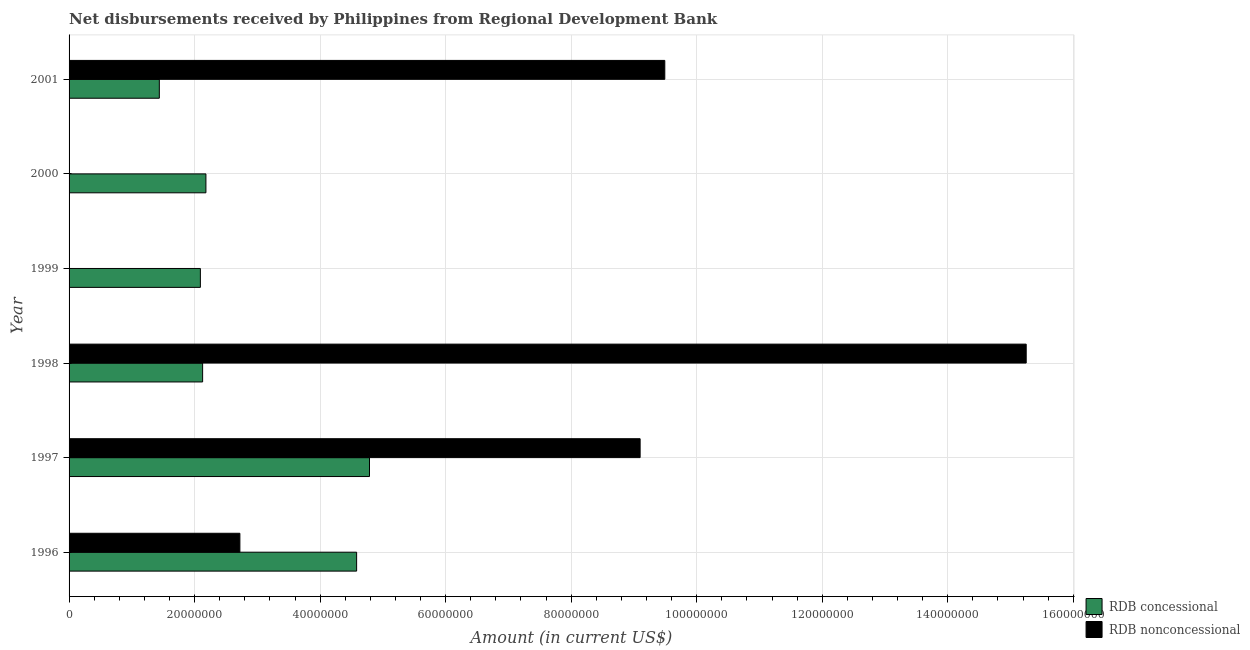Are the number of bars per tick equal to the number of legend labels?
Give a very brief answer. No. What is the label of the 6th group of bars from the top?
Offer a terse response. 1996. What is the net non concessional disbursements from rdb in 2001?
Give a very brief answer. 9.49e+07. Across all years, what is the maximum net non concessional disbursements from rdb?
Ensure brevity in your answer.  1.53e+08. Across all years, what is the minimum net concessional disbursements from rdb?
Offer a terse response. 1.44e+07. What is the total net non concessional disbursements from rdb in the graph?
Make the answer very short. 3.66e+08. What is the difference between the net concessional disbursements from rdb in 1996 and that in 2001?
Make the answer very short. 3.14e+07. What is the difference between the net concessional disbursements from rdb in 2000 and the net non concessional disbursements from rdb in 1998?
Your response must be concise. -1.31e+08. What is the average net non concessional disbursements from rdb per year?
Your response must be concise. 6.09e+07. In the year 1998, what is the difference between the net non concessional disbursements from rdb and net concessional disbursements from rdb?
Your answer should be very brief. 1.31e+08. What is the ratio of the net concessional disbursements from rdb in 1996 to that in 2001?
Keep it short and to the point. 3.19. Is the net concessional disbursements from rdb in 1996 less than that in 2000?
Your answer should be compact. No. What is the difference between the highest and the second highest net concessional disbursements from rdb?
Offer a very short reply. 2.05e+06. What is the difference between the highest and the lowest net concessional disbursements from rdb?
Offer a very short reply. 3.35e+07. In how many years, is the net non concessional disbursements from rdb greater than the average net non concessional disbursements from rdb taken over all years?
Give a very brief answer. 3. How many bars are there?
Your response must be concise. 10. How many years are there in the graph?
Provide a succinct answer. 6. What is the difference between two consecutive major ticks on the X-axis?
Give a very brief answer. 2.00e+07. Does the graph contain any zero values?
Offer a very short reply. Yes. Where does the legend appear in the graph?
Keep it short and to the point. Bottom right. How are the legend labels stacked?
Your answer should be very brief. Vertical. What is the title of the graph?
Offer a very short reply. Net disbursements received by Philippines from Regional Development Bank. Does "Domestic Liabilities" appear as one of the legend labels in the graph?
Make the answer very short. No. What is the label or title of the X-axis?
Your answer should be very brief. Amount (in current US$). What is the Amount (in current US$) of RDB concessional in 1996?
Your answer should be compact. 4.58e+07. What is the Amount (in current US$) in RDB nonconcessional in 1996?
Your response must be concise. 2.72e+07. What is the Amount (in current US$) of RDB concessional in 1997?
Offer a very short reply. 4.79e+07. What is the Amount (in current US$) in RDB nonconcessional in 1997?
Make the answer very short. 9.10e+07. What is the Amount (in current US$) in RDB concessional in 1998?
Provide a succinct answer. 2.13e+07. What is the Amount (in current US$) of RDB nonconcessional in 1998?
Offer a very short reply. 1.53e+08. What is the Amount (in current US$) in RDB concessional in 1999?
Keep it short and to the point. 2.09e+07. What is the Amount (in current US$) of RDB nonconcessional in 1999?
Keep it short and to the point. 0. What is the Amount (in current US$) of RDB concessional in 2000?
Your response must be concise. 2.18e+07. What is the Amount (in current US$) of RDB concessional in 2001?
Your response must be concise. 1.44e+07. What is the Amount (in current US$) in RDB nonconcessional in 2001?
Your answer should be very brief. 9.49e+07. Across all years, what is the maximum Amount (in current US$) in RDB concessional?
Provide a succinct answer. 4.79e+07. Across all years, what is the maximum Amount (in current US$) in RDB nonconcessional?
Give a very brief answer. 1.53e+08. Across all years, what is the minimum Amount (in current US$) in RDB concessional?
Provide a short and direct response. 1.44e+07. Across all years, what is the minimum Amount (in current US$) in RDB nonconcessional?
Your answer should be compact. 0. What is the total Amount (in current US$) of RDB concessional in the graph?
Provide a short and direct response. 1.72e+08. What is the total Amount (in current US$) in RDB nonconcessional in the graph?
Your response must be concise. 3.66e+08. What is the difference between the Amount (in current US$) in RDB concessional in 1996 and that in 1997?
Your response must be concise. -2.05e+06. What is the difference between the Amount (in current US$) of RDB nonconcessional in 1996 and that in 1997?
Offer a very short reply. -6.38e+07. What is the difference between the Amount (in current US$) of RDB concessional in 1996 and that in 1998?
Your answer should be very brief. 2.45e+07. What is the difference between the Amount (in current US$) of RDB nonconcessional in 1996 and that in 1998?
Provide a short and direct response. -1.25e+08. What is the difference between the Amount (in current US$) in RDB concessional in 1996 and that in 1999?
Your response must be concise. 2.49e+07. What is the difference between the Amount (in current US$) of RDB concessional in 1996 and that in 2000?
Provide a short and direct response. 2.40e+07. What is the difference between the Amount (in current US$) of RDB concessional in 1996 and that in 2001?
Your answer should be compact. 3.14e+07. What is the difference between the Amount (in current US$) of RDB nonconcessional in 1996 and that in 2001?
Provide a short and direct response. -6.77e+07. What is the difference between the Amount (in current US$) in RDB concessional in 1997 and that in 1998?
Ensure brevity in your answer.  2.66e+07. What is the difference between the Amount (in current US$) in RDB nonconcessional in 1997 and that in 1998?
Your response must be concise. -6.15e+07. What is the difference between the Amount (in current US$) in RDB concessional in 1997 and that in 1999?
Make the answer very short. 2.69e+07. What is the difference between the Amount (in current US$) of RDB concessional in 1997 and that in 2000?
Make the answer very short. 2.61e+07. What is the difference between the Amount (in current US$) of RDB concessional in 1997 and that in 2001?
Offer a terse response. 3.35e+07. What is the difference between the Amount (in current US$) in RDB nonconcessional in 1997 and that in 2001?
Provide a succinct answer. -3.93e+06. What is the difference between the Amount (in current US$) of RDB concessional in 1998 and that in 1999?
Provide a short and direct response. 3.59e+05. What is the difference between the Amount (in current US$) of RDB concessional in 1998 and that in 2000?
Your response must be concise. -5.25e+05. What is the difference between the Amount (in current US$) of RDB concessional in 1998 and that in 2001?
Offer a very short reply. 6.90e+06. What is the difference between the Amount (in current US$) in RDB nonconcessional in 1998 and that in 2001?
Your response must be concise. 5.76e+07. What is the difference between the Amount (in current US$) in RDB concessional in 1999 and that in 2000?
Ensure brevity in your answer.  -8.84e+05. What is the difference between the Amount (in current US$) of RDB concessional in 1999 and that in 2001?
Your answer should be compact. 6.54e+06. What is the difference between the Amount (in current US$) of RDB concessional in 2000 and that in 2001?
Your answer should be very brief. 7.42e+06. What is the difference between the Amount (in current US$) of RDB concessional in 1996 and the Amount (in current US$) of RDB nonconcessional in 1997?
Offer a terse response. -4.52e+07. What is the difference between the Amount (in current US$) of RDB concessional in 1996 and the Amount (in current US$) of RDB nonconcessional in 1998?
Offer a very short reply. -1.07e+08. What is the difference between the Amount (in current US$) in RDB concessional in 1996 and the Amount (in current US$) in RDB nonconcessional in 2001?
Offer a terse response. -4.91e+07. What is the difference between the Amount (in current US$) of RDB concessional in 1997 and the Amount (in current US$) of RDB nonconcessional in 1998?
Offer a very short reply. -1.05e+08. What is the difference between the Amount (in current US$) of RDB concessional in 1997 and the Amount (in current US$) of RDB nonconcessional in 2001?
Offer a very short reply. -4.70e+07. What is the difference between the Amount (in current US$) of RDB concessional in 1998 and the Amount (in current US$) of RDB nonconcessional in 2001?
Offer a terse response. -7.36e+07. What is the difference between the Amount (in current US$) of RDB concessional in 1999 and the Amount (in current US$) of RDB nonconcessional in 2001?
Offer a very short reply. -7.40e+07. What is the difference between the Amount (in current US$) in RDB concessional in 2000 and the Amount (in current US$) in RDB nonconcessional in 2001?
Provide a succinct answer. -7.31e+07. What is the average Amount (in current US$) in RDB concessional per year?
Provide a short and direct response. 2.87e+07. What is the average Amount (in current US$) of RDB nonconcessional per year?
Make the answer very short. 6.09e+07. In the year 1996, what is the difference between the Amount (in current US$) in RDB concessional and Amount (in current US$) in RDB nonconcessional?
Offer a very short reply. 1.86e+07. In the year 1997, what is the difference between the Amount (in current US$) in RDB concessional and Amount (in current US$) in RDB nonconcessional?
Ensure brevity in your answer.  -4.31e+07. In the year 1998, what is the difference between the Amount (in current US$) of RDB concessional and Amount (in current US$) of RDB nonconcessional?
Keep it short and to the point. -1.31e+08. In the year 2001, what is the difference between the Amount (in current US$) of RDB concessional and Amount (in current US$) of RDB nonconcessional?
Offer a very short reply. -8.05e+07. What is the ratio of the Amount (in current US$) of RDB concessional in 1996 to that in 1997?
Your answer should be very brief. 0.96. What is the ratio of the Amount (in current US$) in RDB nonconcessional in 1996 to that in 1997?
Keep it short and to the point. 0.3. What is the ratio of the Amount (in current US$) in RDB concessional in 1996 to that in 1998?
Give a very brief answer. 2.15. What is the ratio of the Amount (in current US$) in RDB nonconcessional in 1996 to that in 1998?
Give a very brief answer. 0.18. What is the ratio of the Amount (in current US$) of RDB concessional in 1996 to that in 1999?
Offer a terse response. 2.19. What is the ratio of the Amount (in current US$) of RDB concessional in 1996 to that in 2000?
Offer a very short reply. 2.1. What is the ratio of the Amount (in current US$) in RDB concessional in 1996 to that in 2001?
Your answer should be compact. 3.19. What is the ratio of the Amount (in current US$) in RDB nonconcessional in 1996 to that in 2001?
Offer a very short reply. 0.29. What is the ratio of the Amount (in current US$) in RDB concessional in 1997 to that in 1998?
Keep it short and to the point. 2.25. What is the ratio of the Amount (in current US$) in RDB nonconcessional in 1997 to that in 1998?
Your response must be concise. 0.6. What is the ratio of the Amount (in current US$) in RDB concessional in 1997 to that in 1999?
Ensure brevity in your answer.  2.29. What is the ratio of the Amount (in current US$) in RDB concessional in 1997 to that in 2000?
Offer a very short reply. 2.2. What is the ratio of the Amount (in current US$) of RDB concessional in 1997 to that in 2001?
Provide a succinct answer. 3.33. What is the ratio of the Amount (in current US$) in RDB nonconcessional in 1997 to that in 2001?
Your answer should be compact. 0.96. What is the ratio of the Amount (in current US$) of RDB concessional in 1998 to that in 1999?
Offer a very short reply. 1.02. What is the ratio of the Amount (in current US$) of RDB concessional in 1998 to that in 2000?
Give a very brief answer. 0.98. What is the ratio of the Amount (in current US$) of RDB concessional in 1998 to that in 2001?
Keep it short and to the point. 1.48. What is the ratio of the Amount (in current US$) in RDB nonconcessional in 1998 to that in 2001?
Keep it short and to the point. 1.61. What is the ratio of the Amount (in current US$) in RDB concessional in 1999 to that in 2000?
Offer a very short reply. 0.96. What is the ratio of the Amount (in current US$) in RDB concessional in 1999 to that in 2001?
Your answer should be very brief. 1.45. What is the ratio of the Amount (in current US$) in RDB concessional in 2000 to that in 2001?
Ensure brevity in your answer.  1.52. What is the difference between the highest and the second highest Amount (in current US$) in RDB concessional?
Offer a very short reply. 2.05e+06. What is the difference between the highest and the second highest Amount (in current US$) in RDB nonconcessional?
Your answer should be compact. 5.76e+07. What is the difference between the highest and the lowest Amount (in current US$) in RDB concessional?
Offer a very short reply. 3.35e+07. What is the difference between the highest and the lowest Amount (in current US$) of RDB nonconcessional?
Your answer should be very brief. 1.53e+08. 